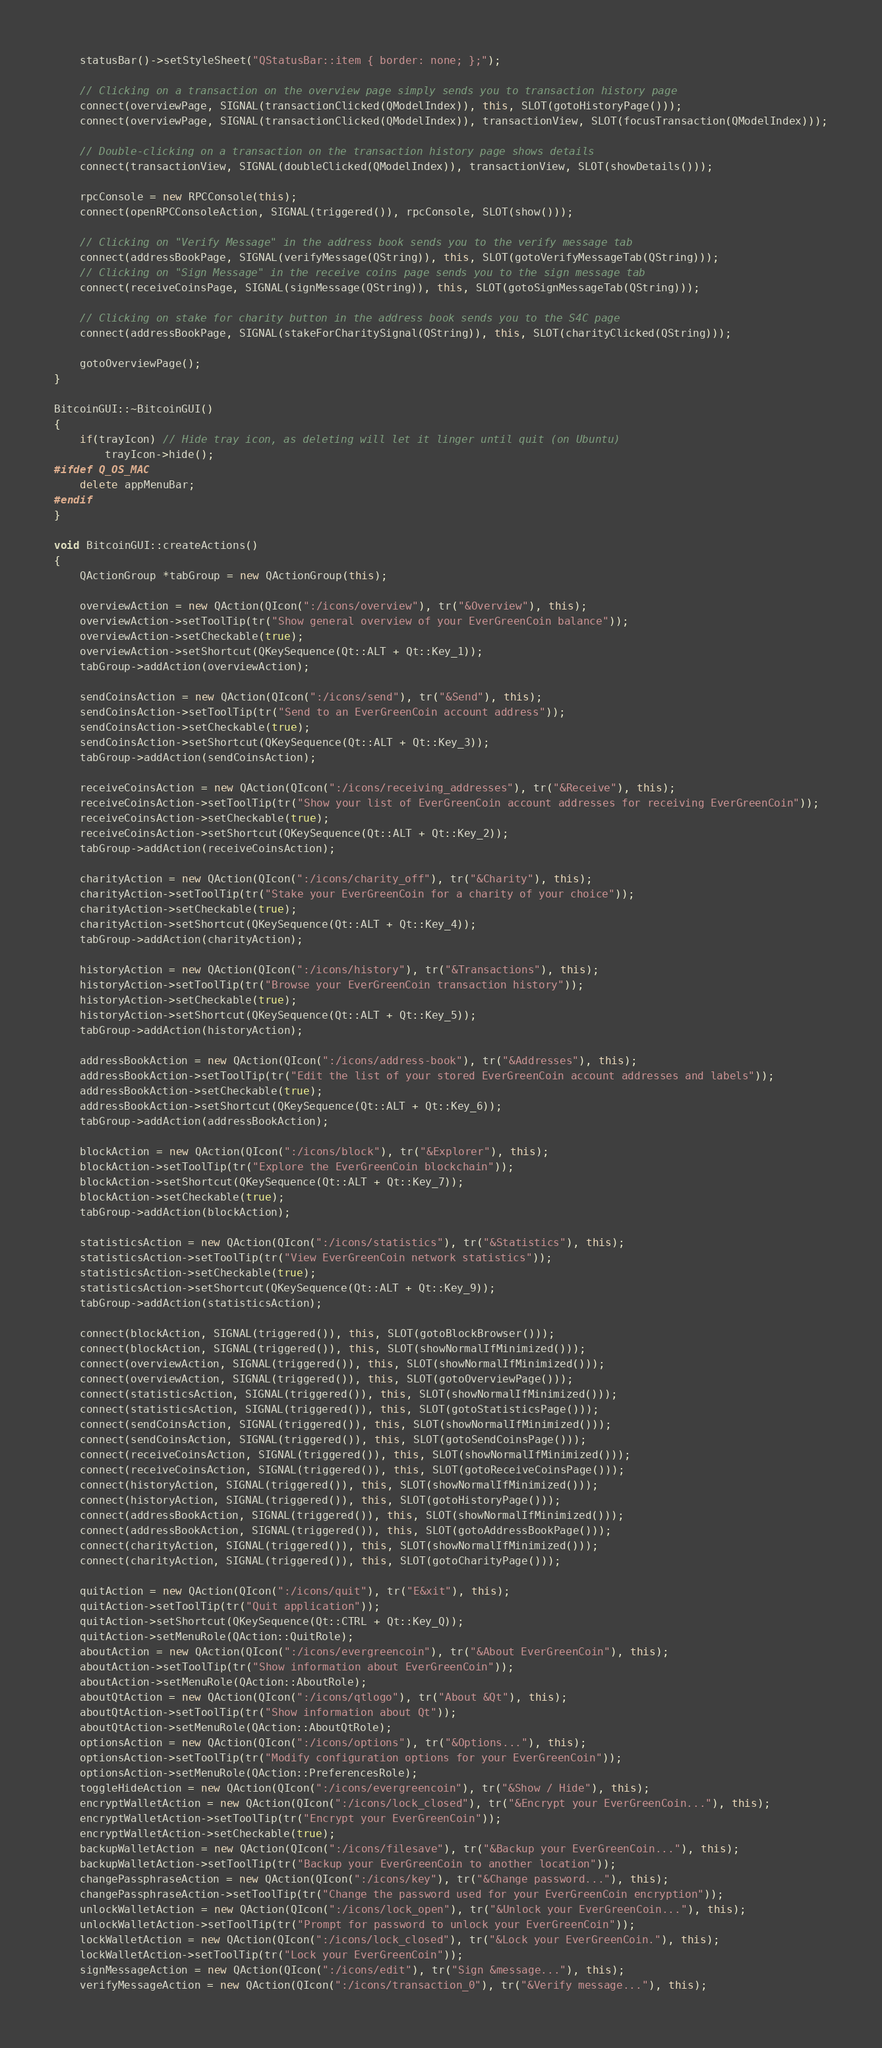<code> <loc_0><loc_0><loc_500><loc_500><_C++_>    statusBar()->setStyleSheet("QStatusBar::item { border: none; };");

    // Clicking on a transaction on the overview page simply sends you to transaction history page
    connect(overviewPage, SIGNAL(transactionClicked(QModelIndex)), this, SLOT(gotoHistoryPage()));
    connect(overviewPage, SIGNAL(transactionClicked(QModelIndex)), transactionView, SLOT(focusTransaction(QModelIndex)));

    // Double-clicking on a transaction on the transaction history page shows details
    connect(transactionView, SIGNAL(doubleClicked(QModelIndex)), transactionView, SLOT(showDetails()));

    rpcConsole = new RPCConsole(this);
    connect(openRPCConsoleAction, SIGNAL(triggered()), rpcConsole, SLOT(show()));

    // Clicking on "Verify Message" in the address book sends you to the verify message tab
    connect(addressBookPage, SIGNAL(verifyMessage(QString)), this, SLOT(gotoVerifyMessageTab(QString)));
    // Clicking on "Sign Message" in the receive coins page sends you to the sign message tab
    connect(receiveCoinsPage, SIGNAL(signMessage(QString)), this, SLOT(gotoSignMessageTab(QString)));

    // Clicking on stake for charity button in the address book sends you to the S4C page
    connect(addressBookPage, SIGNAL(stakeForCharitySignal(QString)), this, SLOT(charityClicked(QString)));

    gotoOverviewPage();
}

BitcoinGUI::~BitcoinGUI()
{
    if(trayIcon) // Hide tray icon, as deleting will let it linger until quit (on Ubuntu)
        trayIcon->hide();
#ifdef Q_OS_MAC
    delete appMenuBar;
#endif
}

void BitcoinGUI::createActions()
{
    QActionGroup *tabGroup = new QActionGroup(this);

    overviewAction = new QAction(QIcon(":/icons/overview"), tr("&Overview"), this);
    overviewAction->setToolTip(tr("Show general overview of your EverGreenCoin balance"));
    overviewAction->setCheckable(true);
    overviewAction->setShortcut(QKeySequence(Qt::ALT + Qt::Key_1));
    tabGroup->addAction(overviewAction);

    sendCoinsAction = new QAction(QIcon(":/icons/send"), tr("&Send"), this);
    sendCoinsAction->setToolTip(tr("Send to an EverGreenCoin account address"));
    sendCoinsAction->setCheckable(true);
    sendCoinsAction->setShortcut(QKeySequence(Qt::ALT + Qt::Key_3));
    tabGroup->addAction(sendCoinsAction);

    receiveCoinsAction = new QAction(QIcon(":/icons/receiving_addresses"), tr("&Receive"), this);
    receiveCoinsAction->setToolTip(tr("Show your list of EverGreenCoin account addresses for receiving EverGreenCoin"));
    receiveCoinsAction->setCheckable(true);
    receiveCoinsAction->setShortcut(QKeySequence(Qt::ALT + Qt::Key_2));
    tabGroup->addAction(receiveCoinsAction);

    charityAction = new QAction(QIcon(":/icons/charity_off"), tr("&Charity"), this);
    charityAction->setToolTip(tr("Stake your EverGreenCoin for a charity of your choice"));
    charityAction->setCheckable(true);
    charityAction->setShortcut(QKeySequence(Qt::ALT + Qt::Key_4));
    tabGroup->addAction(charityAction);

    historyAction = new QAction(QIcon(":/icons/history"), tr("&Transactions"), this);
    historyAction->setToolTip(tr("Browse your EverGreenCoin transaction history"));
    historyAction->setCheckable(true);
    historyAction->setShortcut(QKeySequence(Qt::ALT + Qt::Key_5));
    tabGroup->addAction(historyAction);

    addressBookAction = new QAction(QIcon(":/icons/address-book"), tr("&Addresses"), this);
    addressBookAction->setToolTip(tr("Edit the list of your stored EverGreenCoin account addresses and labels"));
    addressBookAction->setCheckable(true);
    addressBookAction->setShortcut(QKeySequence(Qt::ALT + Qt::Key_6));
    tabGroup->addAction(addressBookAction);

    blockAction = new QAction(QIcon(":/icons/block"), tr("&Explorer"), this);
    blockAction->setToolTip(tr("Explore the EverGreenCoin blockchain"));
    blockAction->setShortcut(QKeySequence(Qt::ALT + Qt::Key_7));
    blockAction->setCheckable(true);
    tabGroup->addAction(blockAction);

    statisticsAction = new QAction(QIcon(":/icons/statistics"), tr("&Statistics"), this);
    statisticsAction->setToolTip(tr("View EverGreenCoin network statistics"));
    statisticsAction->setCheckable(true);
    statisticsAction->setShortcut(QKeySequence(Qt::ALT + Qt::Key_9));
    tabGroup->addAction(statisticsAction);

    connect(blockAction, SIGNAL(triggered()), this, SLOT(gotoBlockBrowser()));
    connect(blockAction, SIGNAL(triggered()), this, SLOT(showNormalIfMinimized()));
    connect(overviewAction, SIGNAL(triggered()), this, SLOT(showNormalIfMinimized()));
    connect(overviewAction, SIGNAL(triggered()), this, SLOT(gotoOverviewPage()));
    connect(statisticsAction, SIGNAL(triggered()), this, SLOT(showNormalIfMinimized()));
    connect(statisticsAction, SIGNAL(triggered()), this, SLOT(gotoStatisticsPage()));
    connect(sendCoinsAction, SIGNAL(triggered()), this, SLOT(showNormalIfMinimized()));
    connect(sendCoinsAction, SIGNAL(triggered()), this, SLOT(gotoSendCoinsPage()));
    connect(receiveCoinsAction, SIGNAL(triggered()), this, SLOT(showNormalIfMinimized()));
    connect(receiveCoinsAction, SIGNAL(triggered()), this, SLOT(gotoReceiveCoinsPage()));
    connect(historyAction, SIGNAL(triggered()), this, SLOT(showNormalIfMinimized()));
    connect(historyAction, SIGNAL(triggered()), this, SLOT(gotoHistoryPage()));
    connect(addressBookAction, SIGNAL(triggered()), this, SLOT(showNormalIfMinimized()));
    connect(addressBookAction, SIGNAL(triggered()), this, SLOT(gotoAddressBookPage()));
    connect(charityAction, SIGNAL(triggered()), this, SLOT(showNormalIfMinimized()));
    connect(charityAction, SIGNAL(triggered()), this, SLOT(gotoCharityPage()));

    quitAction = new QAction(QIcon(":/icons/quit"), tr("E&xit"), this);
    quitAction->setToolTip(tr("Quit application"));
    quitAction->setShortcut(QKeySequence(Qt::CTRL + Qt::Key_Q));
    quitAction->setMenuRole(QAction::QuitRole);
    aboutAction = new QAction(QIcon(":/icons/evergreencoin"), tr("&About EverGreenCoin"), this);
    aboutAction->setToolTip(tr("Show information about EverGreenCoin"));
    aboutAction->setMenuRole(QAction::AboutRole);
    aboutQtAction = new QAction(QIcon(":/icons/qtlogo"), tr("About &Qt"), this);
    aboutQtAction->setToolTip(tr("Show information about Qt"));
    aboutQtAction->setMenuRole(QAction::AboutQtRole);
    optionsAction = new QAction(QIcon(":/icons/options"), tr("&Options..."), this);
    optionsAction->setToolTip(tr("Modify configuration options for your EverGreenCoin"));
    optionsAction->setMenuRole(QAction::PreferencesRole);
    toggleHideAction = new QAction(QIcon(":/icons/evergreencoin"), tr("&Show / Hide"), this);
    encryptWalletAction = new QAction(QIcon(":/icons/lock_closed"), tr("&Encrypt your EverGreenCoin..."), this);
    encryptWalletAction->setToolTip(tr("Encrypt your EverGreenCoin"));
    encryptWalletAction->setCheckable(true);
    backupWalletAction = new QAction(QIcon(":/icons/filesave"), tr("&Backup your EverGreenCoin..."), this);
    backupWalletAction->setToolTip(tr("Backup your EverGreenCoin to another location"));
    changePassphraseAction = new QAction(QIcon(":/icons/key"), tr("&Change password..."), this);
    changePassphraseAction->setToolTip(tr("Change the password used for your EverGreenCoin encryption"));
    unlockWalletAction = new QAction(QIcon(":/icons/lock_open"), tr("&Unlock your EverGreenCoin..."), this);
    unlockWalletAction->setToolTip(tr("Prompt for password to unlock your EverGreenCoin"));
    lockWalletAction = new QAction(QIcon(":/icons/lock_closed"), tr("&Lock your EverGreenCoin."), this);
    lockWalletAction->setToolTip(tr("Lock your EverGreenCoin"));
    signMessageAction = new QAction(QIcon(":/icons/edit"), tr("Sign &message..."), this);
    verifyMessageAction = new QAction(QIcon(":/icons/transaction_0"), tr("&Verify message..."), this);
</code> 